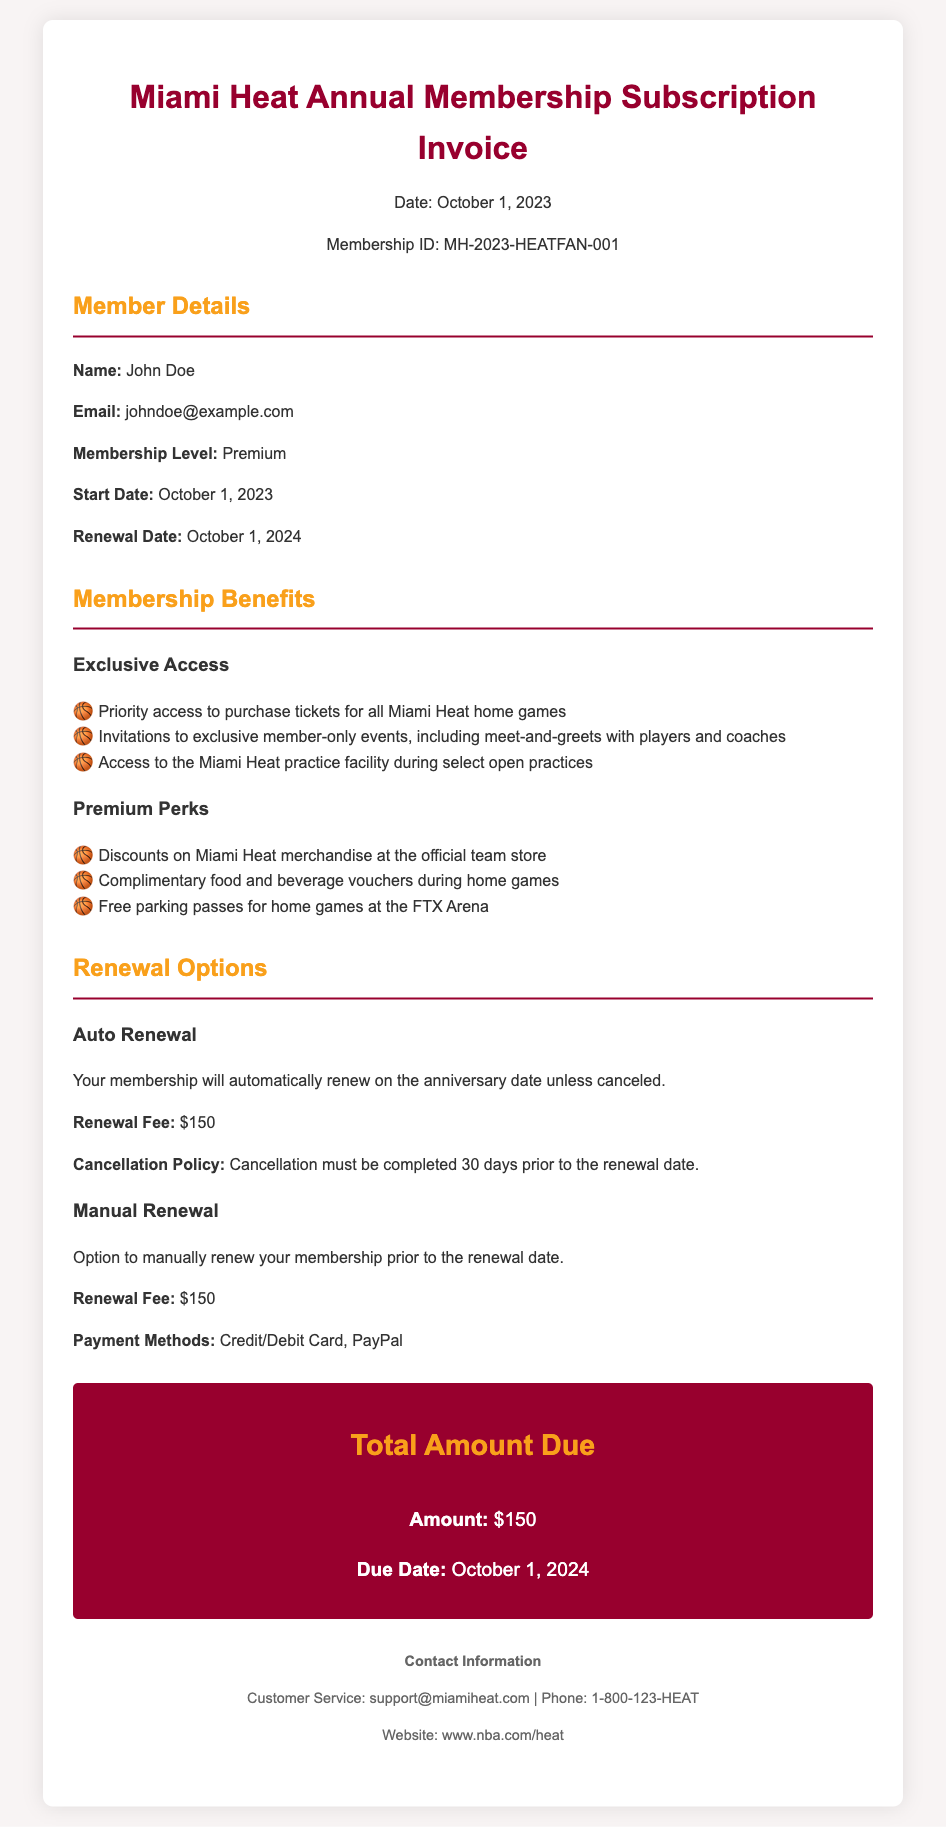What is the membership ID? The membership ID is a unique identifier for the subscription, listed as MH-2023-HEATFAN-001.
Answer: MH-2023-HEATFAN-001 What is the renewal fee? The renewal fee for the membership is stated in both auto and manual renewal sections as $150.
Answer: $150 When does the membership start? The start date of the membership is explicitly mentioned as October 1, 2023.
Answer: October 1, 2023 What is the cancellation policy for auto-renewal? The cancellation policy requires that the cancellation must be completed 30 days prior to the renewal date, indicating a specific time frame for action.
Answer: 30 days What is included in the Premium Perks? The Premium Perks list includes discounts on merchandise, complimentary vouchers during games, and free parking passes.
Answer: Discounts on merchandise, complimentary food and beverage vouchers during home games, free parking passes How many exclusive access features are there? There are three features listed under Exclusive Access for members, including priority ticket access, exclusive events, and practice facility access.
Answer: Three What date is the total amount due? The document specifies that the total amount of $150 is due on October 1, 2024.
Answer: October 1, 2024 Can the membership be manually renewed? The document states that there is an option for manual renewal prior to the renewal date, indicating flexibility for the member.
Answer: Yes What is the primary method of contact for customer support? The primary method of contact is provided as an email address, support@miamiheat.com, along with a phone number.
Answer: support@miamiheat.com 